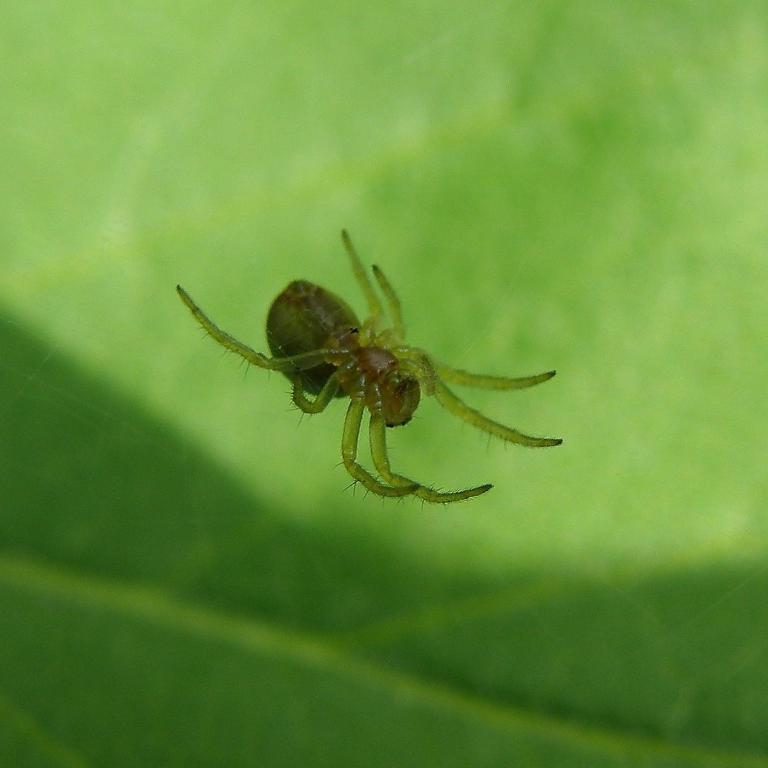What is the main subject in the center of the image? There is a spider in the center of the image. What color is the object in the background of the image? There is a green color object in the background of the image. How many geese are flying in the image? There are no geese present in the image. What statement does the spider make in the image? The spider does not make any statements in the image, as it is an inanimate object. 